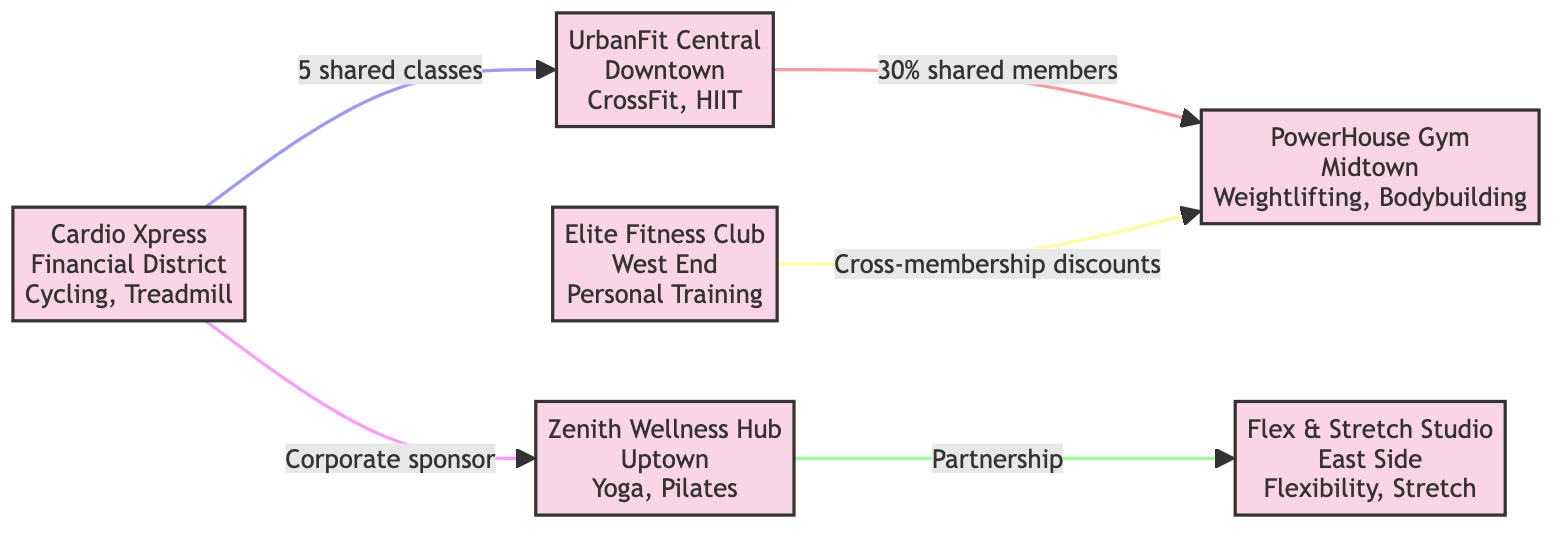What gym is located in Downtown? The diagram indicates that UrbanFit Central is the gym located in Downtown. Each node shows the name and location of the gym clearly.
Answer: UrbanFit Central How many memberships does UrbanFit Central offer? In the diagram, UrbanFit Central lists "Standard" and "Premium" as its memberships. Hence, a count of the memberships shows there are two offered.
Answer: 2 What percentage of members is shared between UrbanFit Central and PowerHouse Gym? The connection between UrbanFit Central and PowerHouse Gym indicates a shared members percentage of 30%. This is stated directly in the relationship description on the edge connecting these two gyms.
Answer: 30% Which two gyms are involved in a partnership? The edge connecting Zenith Wellness Hub to Flex & Stretch Studio indicates a "Partnership" relationship. The diagram specifies the nature of their collaboration, identifying them clearly.
Answer: Zenith Wellness Hub and Flex & Stretch Studio How many shared classes are there between Cardio Xpress and UrbanFit Central? The link between Cardio Xpress and UrbanFit Central states there are 5 shared classes, which is detailed on the edge connecting these two gyms.
Answer: 5 What type of relationship exists between Elite Fitness Club and PowerHouse Gym? The diagram shows that the relationship between Elite Fitness Club and PowerHouse Gym is defined as "membership transfer." This is clearly labeled on the connecting edge.
Answer: membership transfer Which gym sponsors Zenith Wellness Hub? The diagram shows a sponsorship link from Cardio Xpress to Zenith Wellness Hub, indicating that Cardio Xpress is the one sponsoring its activities.
Answer: Cardio Xpress What is the specialization of Flex & Stretch Studio? The node for Flex & Stretch Studio mentions its specializations as "Flexibility Training" and "Stretch Classes," which answers the question about what it focuses on.
Answer: Flexibility Training, Stretch Classes 